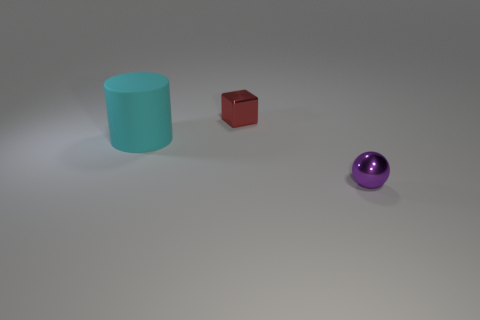There is a tiny shiny thing that is left of the thing that is in front of the matte cylinder; what number of tiny things are to the right of it?
Your response must be concise. 1. What number of things are behind the purple shiny thing and in front of the red thing?
Your answer should be very brief. 1. Is the number of metallic balls that are in front of the purple object greater than the number of large gray rubber spheres?
Provide a short and direct response. No. What number of rubber cylinders have the same size as the purple sphere?
Provide a short and direct response. 0. How many large objects are either purple metallic objects or matte objects?
Offer a very short reply. 1. How many rubber blocks are there?
Provide a short and direct response. 0. Is the number of cyan cylinders behind the cylinder the same as the number of tiny red cubes behind the small purple metallic sphere?
Your answer should be very brief. No. There is a tiny shiny block; are there any tiny purple shiny balls on the left side of it?
Provide a short and direct response. No. What color is the small thing that is in front of the big object?
Offer a terse response. Purple. There is a tiny thing on the left side of the tiny purple metal thing that is to the right of the rubber thing; what is it made of?
Keep it short and to the point. Metal. 